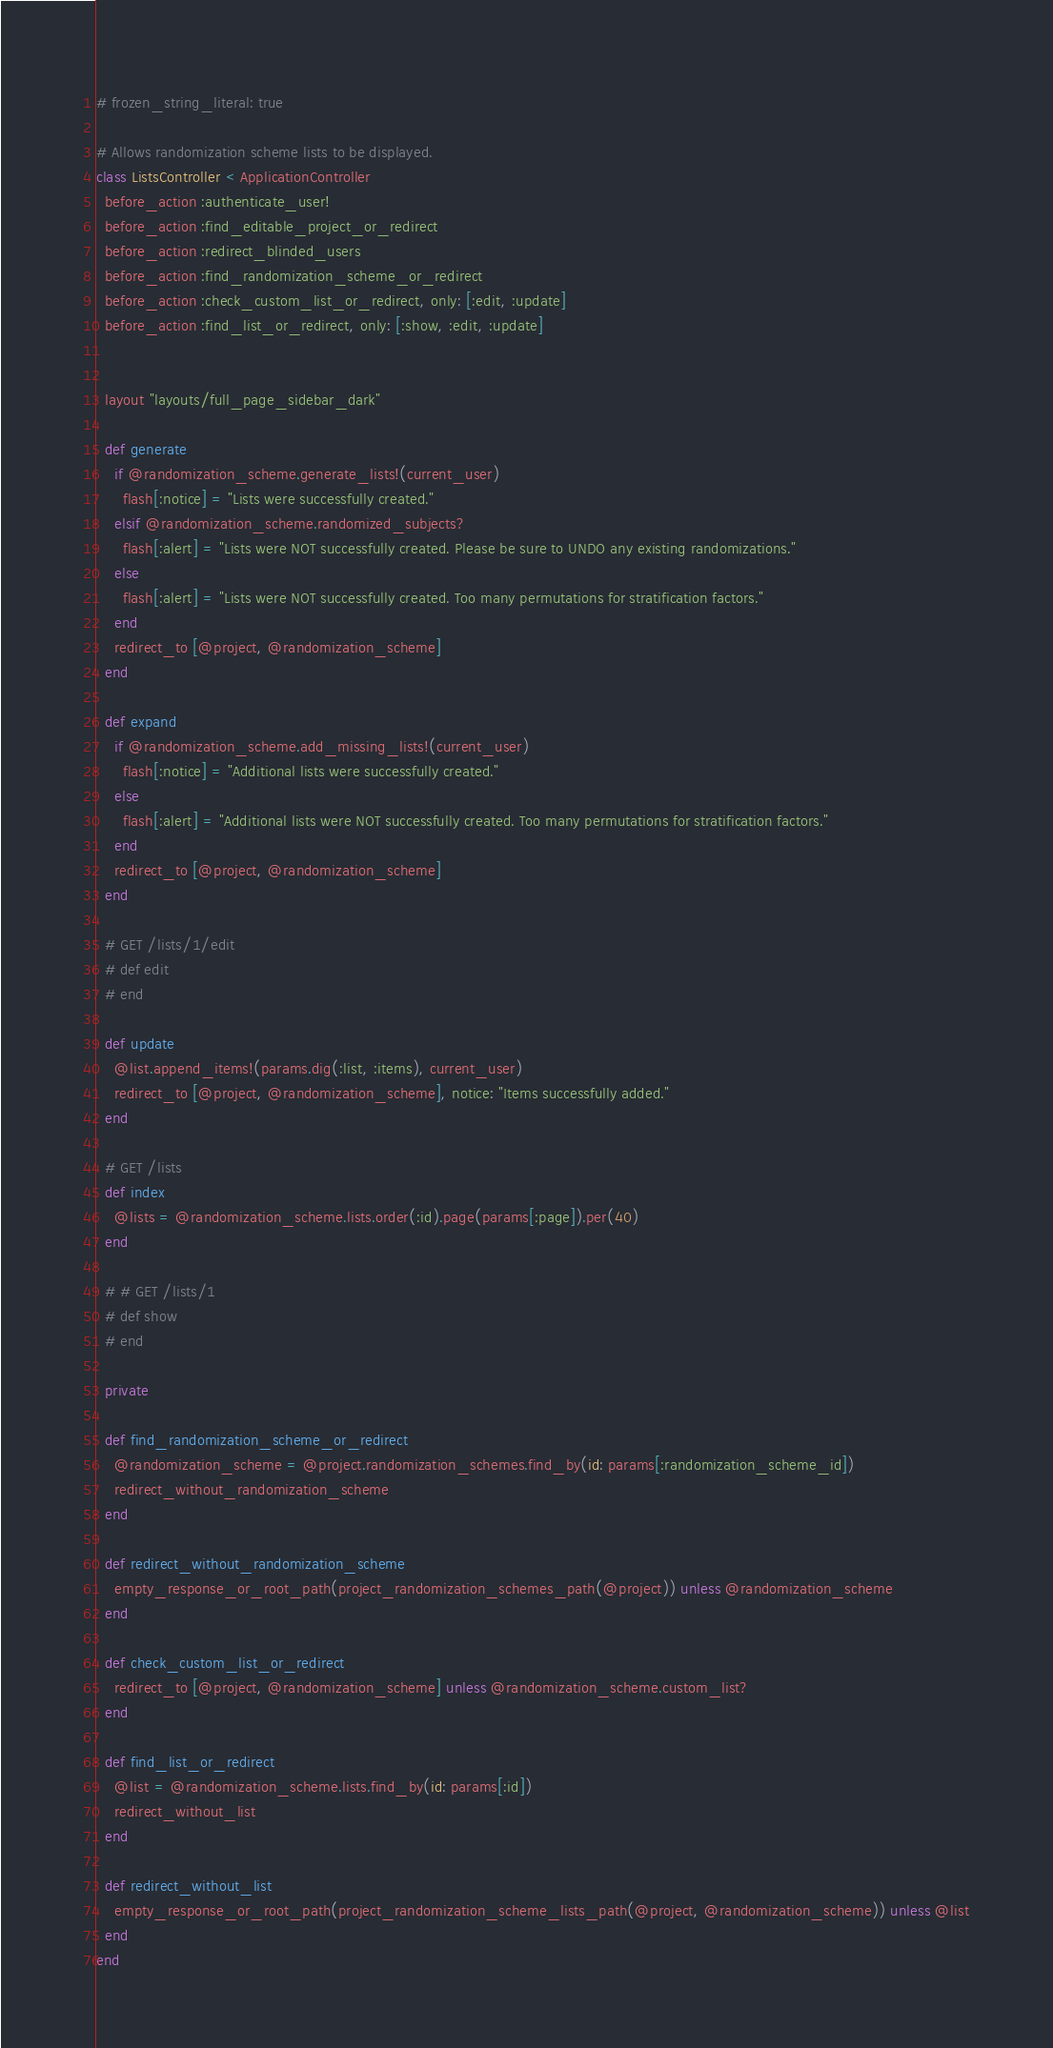<code> <loc_0><loc_0><loc_500><loc_500><_Ruby_># frozen_string_literal: true

# Allows randomization scheme lists to be displayed.
class ListsController < ApplicationController
  before_action :authenticate_user!
  before_action :find_editable_project_or_redirect
  before_action :redirect_blinded_users
  before_action :find_randomization_scheme_or_redirect
  before_action :check_custom_list_or_redirect, only: [:edit, :update]
  before_action :find_list_or_redirect, only: [:show, :edit, :update]


  layout "layouts/full_page_sidebar_dark"

  def generate
    if @randomization_scheme.generate_lists!(current_user)
      flash[:notice] = "Lists were successfully created."
    elsif @randomization_scheme.randomized_subjects?
      flash[:alert] = "Lists were NOT successfully created. Please be sure to UNDO any existing randomizations."
    else
      flash[:alert] = "Lists were NOT successfully created. Too many permutations for stratification factors."
    end
    redirect_to [@project, @randomization_scheme]
  end

  def expand
    if @randomization_scheme.add_missing_lists!(current_user)
      flash[:notice] = "Additional lists were successfully created."
    else
      flash[:alert] = "Additional lists were NOT successfully created. Too many permutations for stratification factors."
    end
    redirect_to [@project, @randomization_scheme]
  end

  # GET /lists/1/edit
  # def edit
  # end

  def update
    @list.append_items!(params.dig(:list, :items), current_user)
    redirect_to [@project, @randomization_scheme], notice: "Items successfully added."
  end

  # GET /lists
  def index
    @lists = @randomization_scheme.lists.order(:id).page(params[:page]).per(40)
  end

  # # GET /lists/1
  # def show
  # end

  private

  def find_randomization_scheme_or_redirect
    @randomization_scheme = @project.randomization_schemes.find_by(id: params[:randomization_scheme_id])
    redirect_without_randomization_scheme
  end

  def redirect_without_randomization_scheme
    empty_response_or_root_path(project_randomization_schemes_path(@project)) unless @randomization_scheme
  end

  def check_custom_list_or_redirect
    redirect_to [@project, @randomization_scheme] unless @randomization_scheme.custom_list?
  end

  def find_list_or_redirect
    @list = @randomization_scheme.lists.find_by(id: params[:id])
    redirect_without_list
  end

  def redirect_without_list
    empty_response_or_root_path(project_randomization_scheme_lists_path(@project, @randomization_scheme)) unless @list
  end
end
</code> 